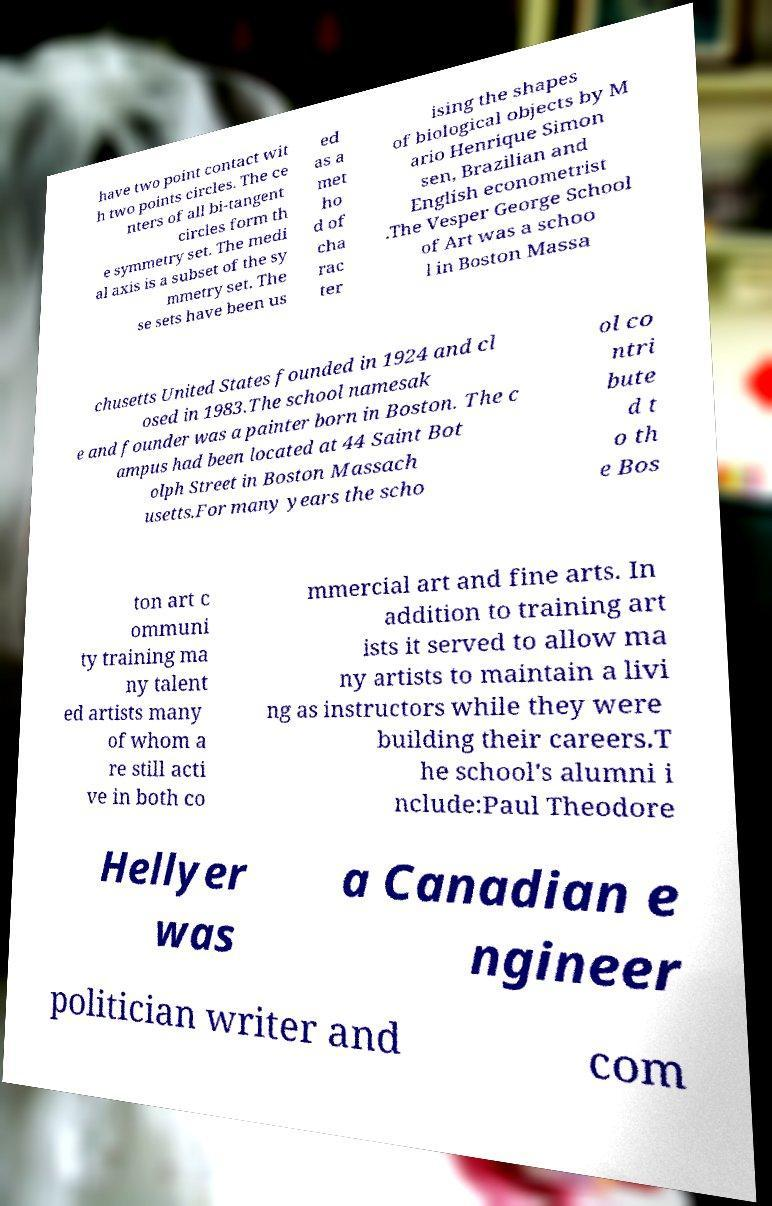Please identify and transcribe the text found in this image. have two point contact wit h two points circles. The ce nters of all bi-tangent circles form th e symmetry set. The medi al axis is a subset of the sy mmetry set. The se sets have been us ed as a met ho d of cha rac ter ising the shapes of biological objects by M ario Henrique Simon sen, Brazilian and English econometrist .The Vesper George School of Art was a schoo l in Boston Massa chusetts United States founded in 1924 and cl osed in 1983.The school namesak e and founder was a painter born in Boston. The c ampus had been located at 44 Saint Bot olph Street in Boston Massach usetts.For many years the scho ol co ntri bute d t o th e Bos ton art c ommuni ty training ma ny talent ed artists many of whom a re still acti ve in both co mmercial art and fine arts. In addition to training art ists it served to allow ma ny artists to maintain a livi ng as instructors while they were building their careers.T he school's alumni i nclude:Paul Theodore Hellyer was a Canadian e ngineer politician writer and com 